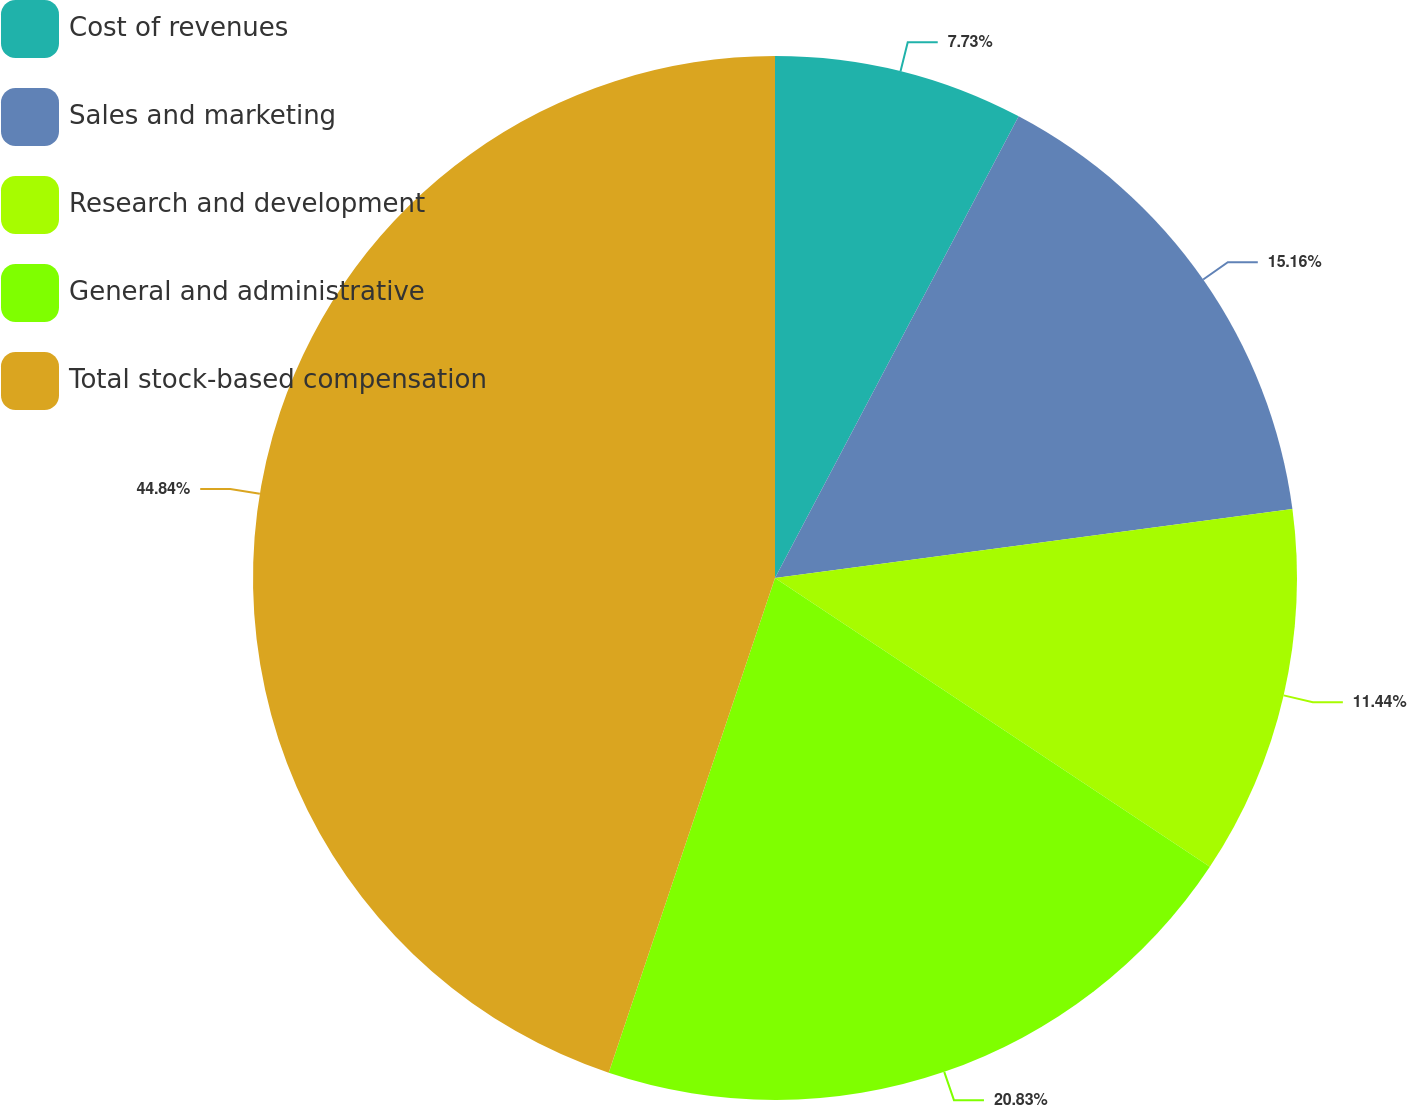Convert chart. <chart><loc_0><loc_0><loc_500><loc_500><pie_chart><fcel>Cost of revenues<fcel>Sales and marketing<fcel>Research and development<fcel>General and administrative<fcel>Total stock-based compensation<nl><fcel>7.73%<fcel>15.16%<fcel>11.44%<fcel>20.83%<fcel>44.84%<nl></chart> 